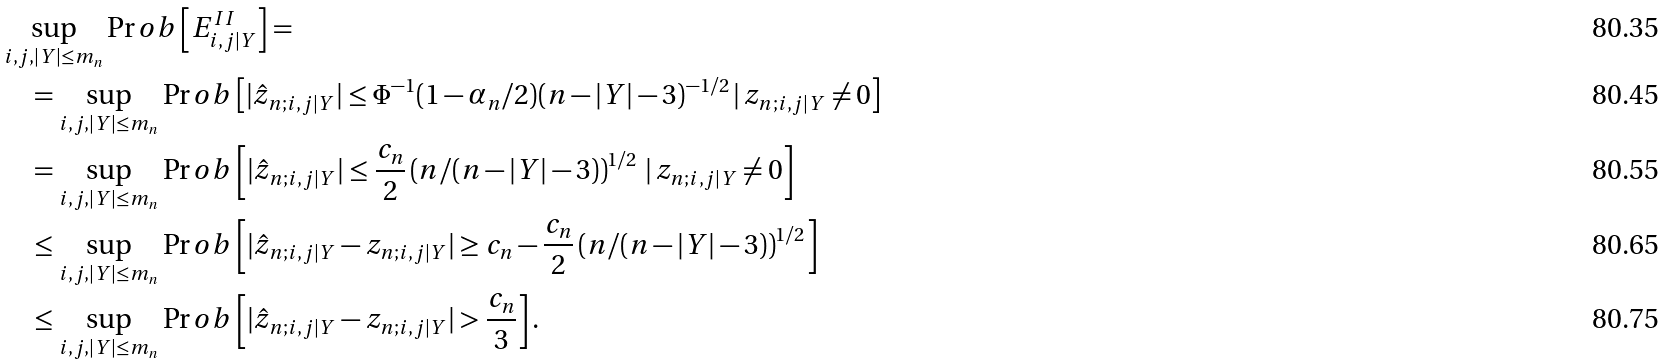Convert formula to latex. <formula><loc_0><loc_0><loc_500><loc_500>& \sup _ { i , j , | Y | \leq m _ { n } } \Pr o b \left [ E ^ { I I } _ { i , j | Y } \right ] = \\ & \quad = \sup _ { i , j , | Y | \leq m _ { n } } \Pr o b \left [ | \hat { z } _ { n ; i , j | Y } | \leq \Phi ^ { - 1 } ( 1 - \alpha _ { n } / 2 ) ( n - | Y | - 3 ) ^ { - 1 / 2 } \, | \, z _ { n ; i , j | Y } \neq 0 \right ] \\ & \quad = \sup _ { i , j , | Y | \leq m _ { n } } \Pr o b \left [ | \hat { z } _ { n ; i , j | Y } | \leq \frac { c _ { n } } { 2 } \left ( n / ( n - | Y | - 3 ) \right ) ^ { 1 / 2 } \, | \, z _ { n ; i , j | Y } \neq 0 \right ] \\ & \quad \leq \sup _ { i , j , | Y | \leq m _ { n } } \Pr o b \left [ | \hat { z } _ { n ; i , j | Y } - z _ { n ; i , j | Y } | \geq c _ { n } - \frac { c _ { n } } { 2 } \left ( n / ( n - | Y | - 3 ) \right ) ^ { 1 / 2 } \right ] \\ & \quad \leq \sup _ { i , j , | Y | \leq m _ { n } } \Pr o b \left [ | \hat { z } _ { n ; i , j | Y } - z _ { n ; i , j | Y } | > \frac { c _ { n } } { 3 } \right ] .</formula> 